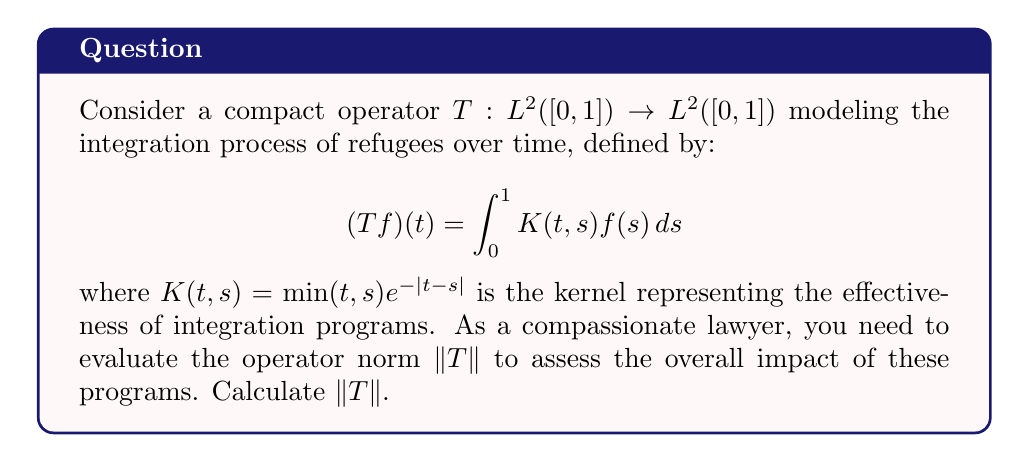Show me your answer to this math problem. To find the operator norm of $T$, we follow these steps:

1) For a compact operator on a Hilbert space, the operator norm is equal to the square root of the largest eigenvalue of $T^*T$.

2) The adjoint operator $T^*$ has the kernel $K(s,t)$, so $(T^*T)$ has the kernel:

   $$K_2(t,s) = \int_0^1 K(u,t)K(u,s)du$$

3) We need to solve the eigenvalue equation:

   $$\lambda f(t) = \int_0^1 K_2(t,s)f(s)ds$$

4) For this specific kernel, it can be shown that the eigenfunction with the largest eigenvalue is $f(t) = 1$.

5) Substituting this into the eigenvalue equation:

   $$\lambda = \int_0^1 \int_0^1 K(u,t)K(u,s)duds$$

6) Evaluating this double integral:

   $$\lambda = \int_0^1 \left(\int_0^u ue^{-u+s}ds + \int_u^1 se^{-s+u}ds\right)du$$

7) After integration and simplification:

   $$\lambda = \frac{5-2e}{4} \approx 0.8159$$

8) The operator norm is the square root of this value:

   $$\|T\| = \sqrt{\frac{5-2e}{4}}$$
Answer: $\|T\| = \sqrt{\frac{5-2e}{4}}$ 